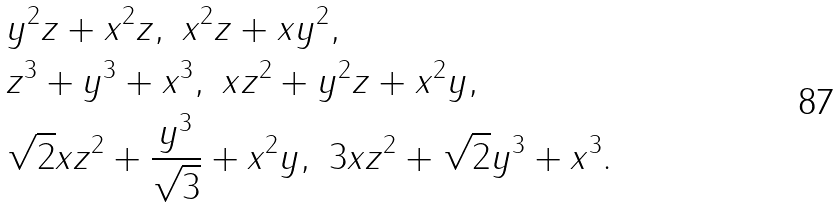Convert formula to latex. <formula><loc_0><loc_0><loc_500><loc_500>& { { y } ^ { 2 } } z + { { x } ^ { 2 } } z , \ { { x } ^ { 2 } } z + x { { y } ^ { 2 } } , \\ & { { z } ^ { 3 } } + { { y } ^ { 3 } } + { { x } ^ { 3 } } , \ x { { z } ^ { 2 } } + { { y } ^ { 2 } } z + { { x } ^ { 2 } } y , \\ & \sqrt { 2 } x { { z } ^ { 2 } } + \frac { { { y } ^ { 3 } } } { \sqrt { 3 } } + { { x } ^ { 2 } } y , \ 3 x { { z } ^ { 2 } } + \sqrt { 2 } { { y } ^ { 3 } } + { { x } ^ { 3 } } .</formula> 